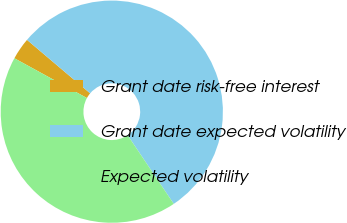Convert chart to OTSL. <chart><loc_0><loc_0><loc_500><loc_500><pie_chart><fcel>Grant date risk-free interest<fcel>Grant date expected volatility<fcel>Expected volatility<nl><fcel>3.2%<fcel>54.4%<fcel>42.4%<nl></chart> 